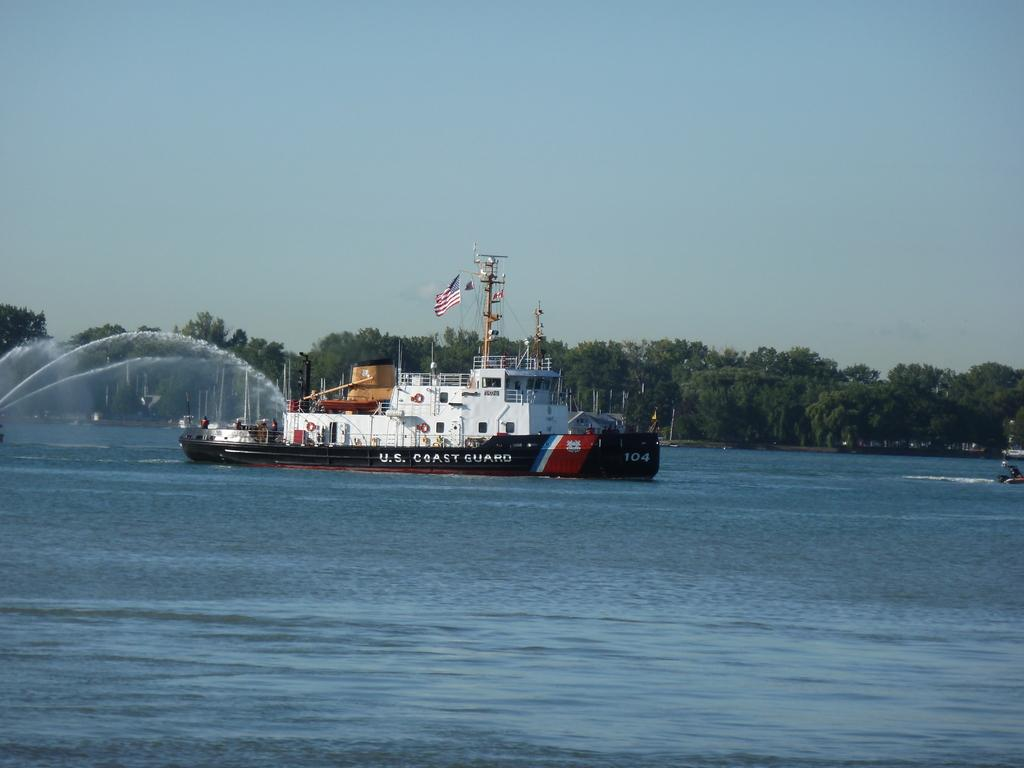What is the main subject of the image? The main subject of the image is a ship on the surface of the water. What can be seen in the background of the image? There are many trees in the background. What is visible at the top of the image? The sky is visible at the top of the image. What additional detail can be observed about the ship? A flag is visible in the image. What time of day is it in the image, and who is the owner of the ship? The time of day cannot be determined from the image, and there is no information provided about the owner of the ship. 